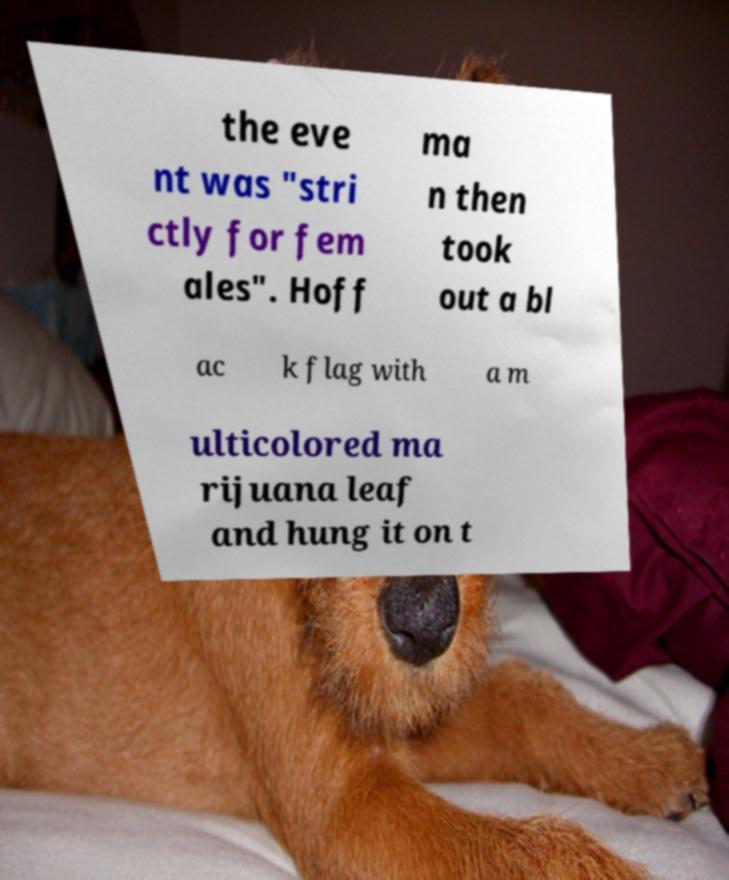Can you read and provide the text displayed in the image?This photo seems to have some interesting text. Can you extract and type it out for me? the eve nt was "stri ctly for fem ales". Hoff ma n then took out a bl ac k flag with a m ulticolored ma rijuana leaf and hung it on t 